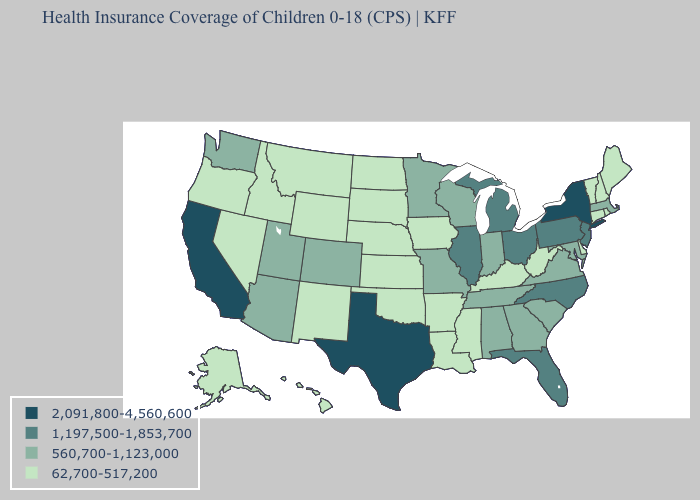Name the states that have a value in the range 2,091,800-4,560,600?
Concise answer only. California, New York, Texas. What is the highest value in the USA?
Short answer required. 2,091,800-4,560,600. Does the map have missing data?
Answer briefly. No. Does the map have missing data?
Be succinct. No. Does Oregon have a lower value than Illinois?
Short answer required. Yes. What is the value of New Mexico?
Short answer required. 62,700-517,200. Name the states that have a value in the range 1,197,500-1,853,700?
Short answer required. Florida, Illinois, Michigan, New Jersey, North Carolina, Ohio, Pennsylvania. Name the states that have a value in the range 62,700-517,200?
Write a very short answer. Alaska, Arkansas, Connecticut, Delaware, Hawaii, Idaho, Iowa, Kansas, Kentucky, Louisiana, Maine, Mississippi, Montana, Nebraska, Nevada, New Hampshire, New Mexico, North Dakota, Oklahoma, Oregon, Rhode Island, South Dakota, Vermont, West Virginia, Wyoming. Does Colorado have a higher value than Oklahoma?
Write a very short answer. Yes. Does the first symbol in the legend represent the smallest category?
Keep it brief. No. Does the first symbol in the legend represent the smallest category?
Concise answer only. No. Does the first symbol in the legend represent the smallest category?
Keep it brief. No. Among the states that border California , does Oregon have the highest value?
Write a very short answer. No. Among the states that border Connecticut , does New York have the highest value?
Concise answer only. Yes. What is the value of South Dakota?
Be succinct. 62,700-517,200. 